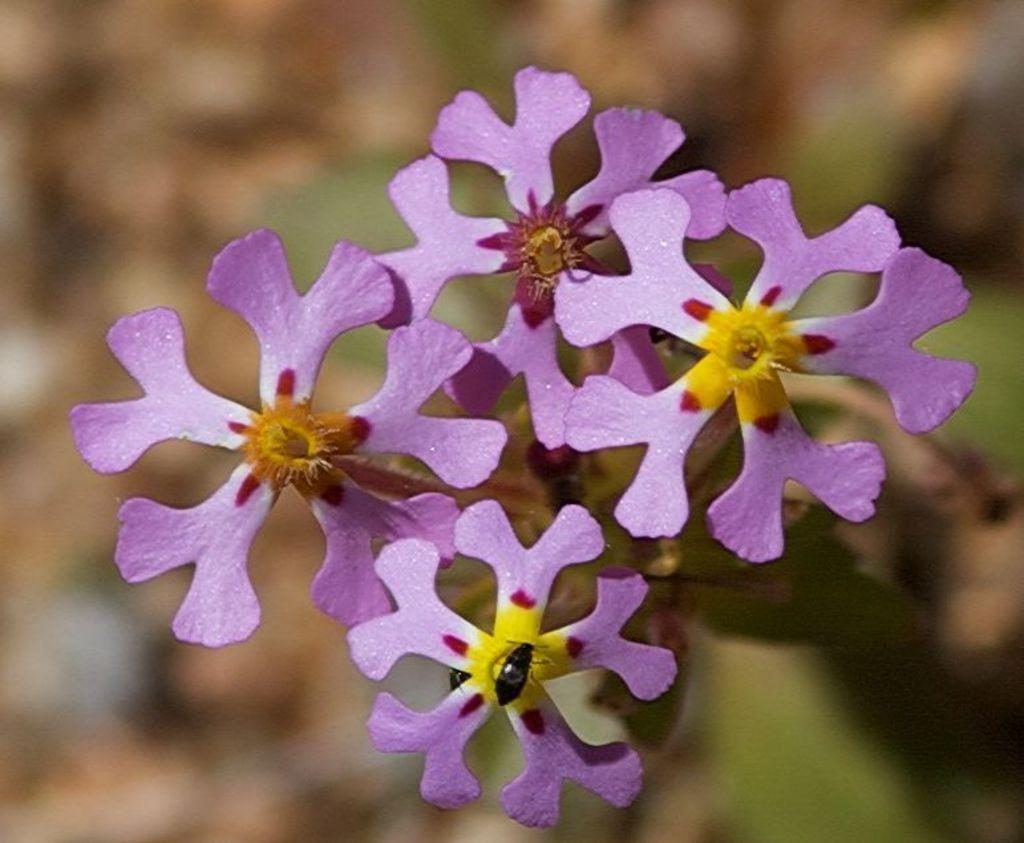What is present on the flower in the image? There is an insect on the flower in the image. What colors are the flowers in the image? The flowers are in purple and yellow colors. How would you describe the background of the image? The background of the image is blurred. How many clocks can be seen hanging on the flower in the image? There are no clocks present in the image; it features an insect on a flower with a blurred background. 